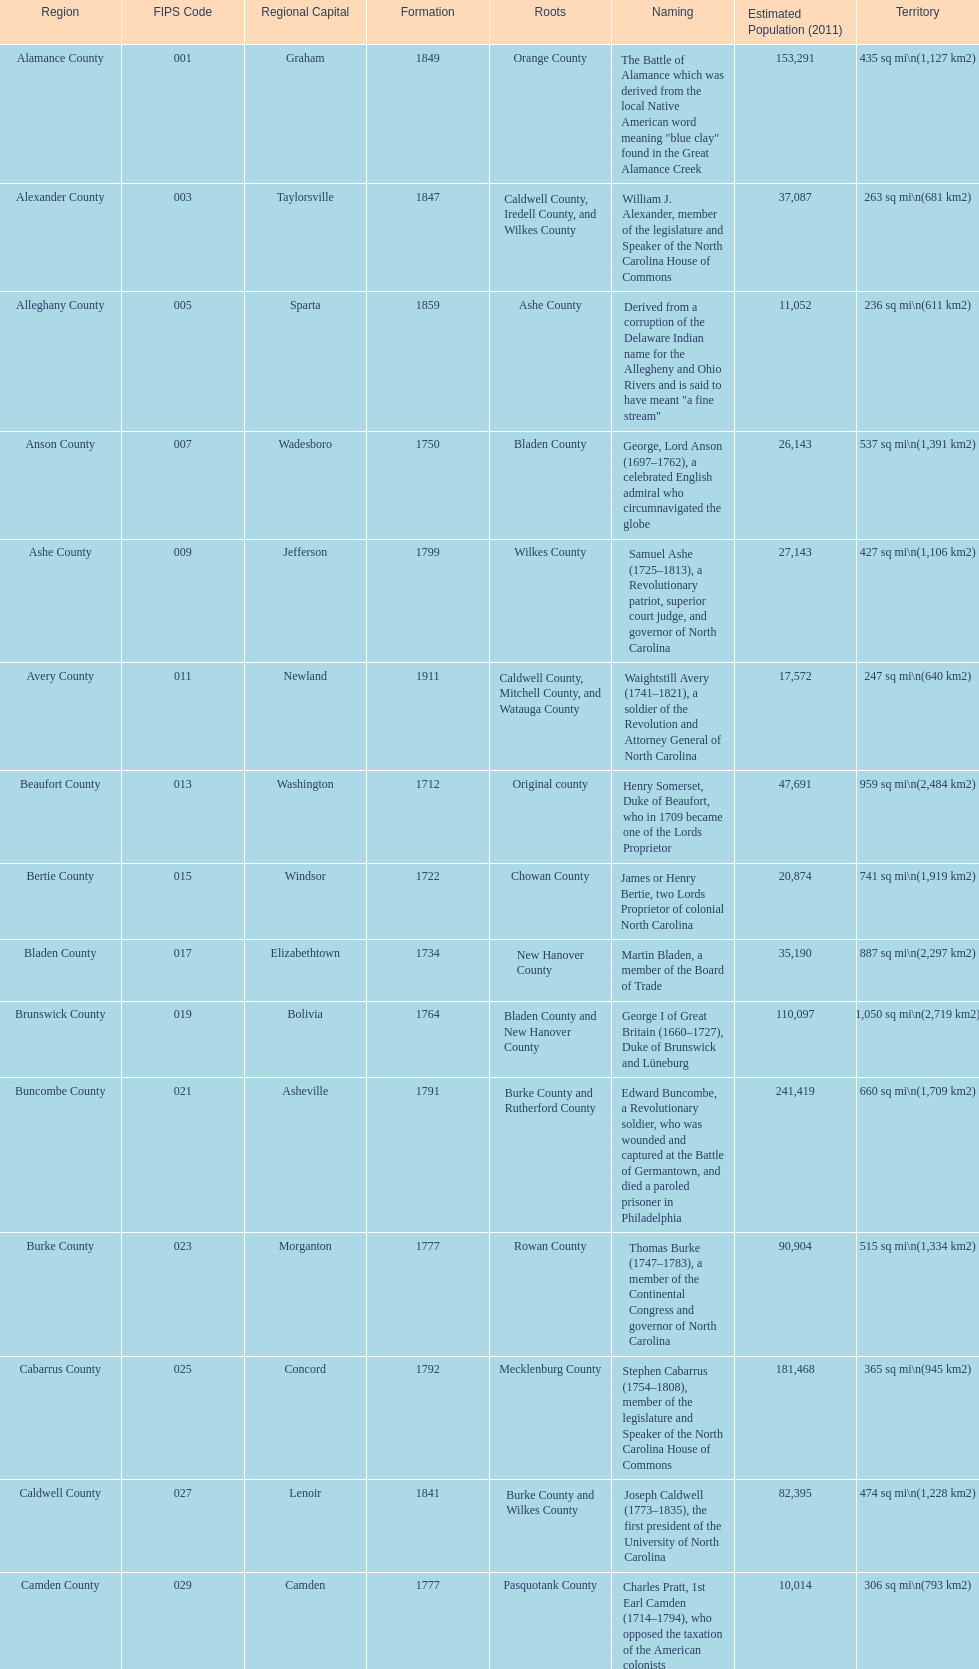What is the number of counties created in the 1800s? 37. 